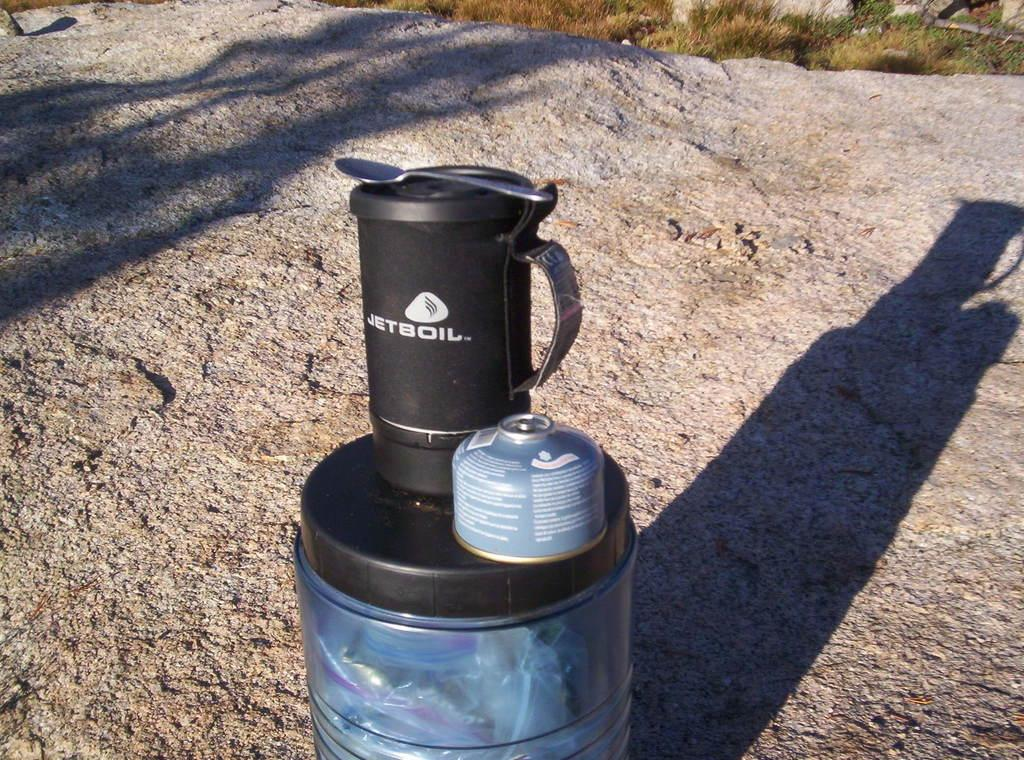<image>
Relay a brief, clear account of the picture shown. A Jetboil brand mug with a spoon on top of it sitting on another tin on a large rock. 